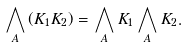<formula> <loc_0><loc_0><loc_500><loc_500>\bigwedge _ { A } \left ( K _ { 1 } K _ { 2 } \right ) = \bigwedge _ { A } K _ { 1 } \bigwedge _ { A } K _ { 2 } .</formula> 